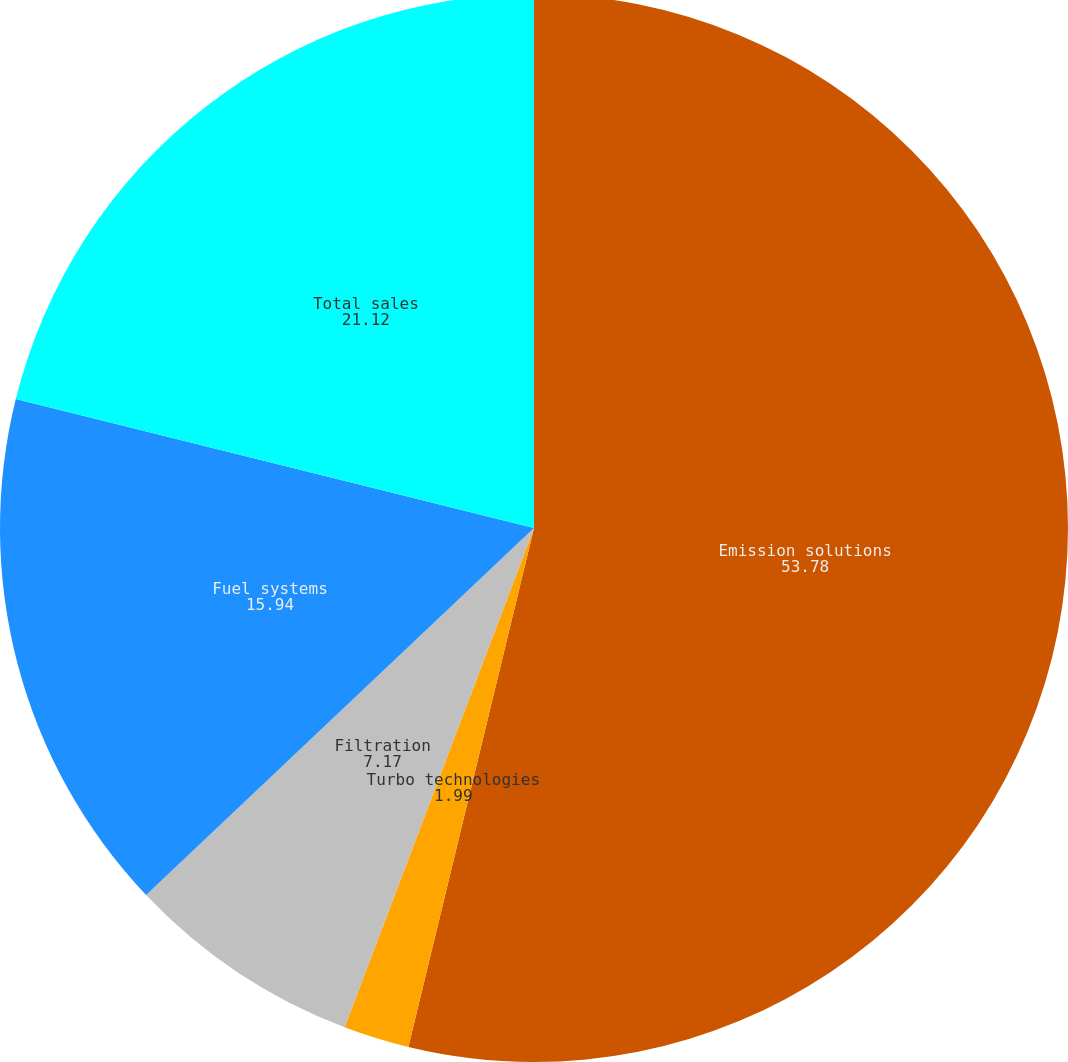Convert chart. <chart><loc_0><loc_0><loc_500><loc_500><pie_chart><fcel>Emission solutions<fcel>Turbo technologies<fcel>Filtration<fcel>Fuel systems<fcel>Total sales<nl><fcel>53.78%<fcel>1.99%<fcel>7.17%<fcel>15.94%<fcel>21.12%<nl></chart> 